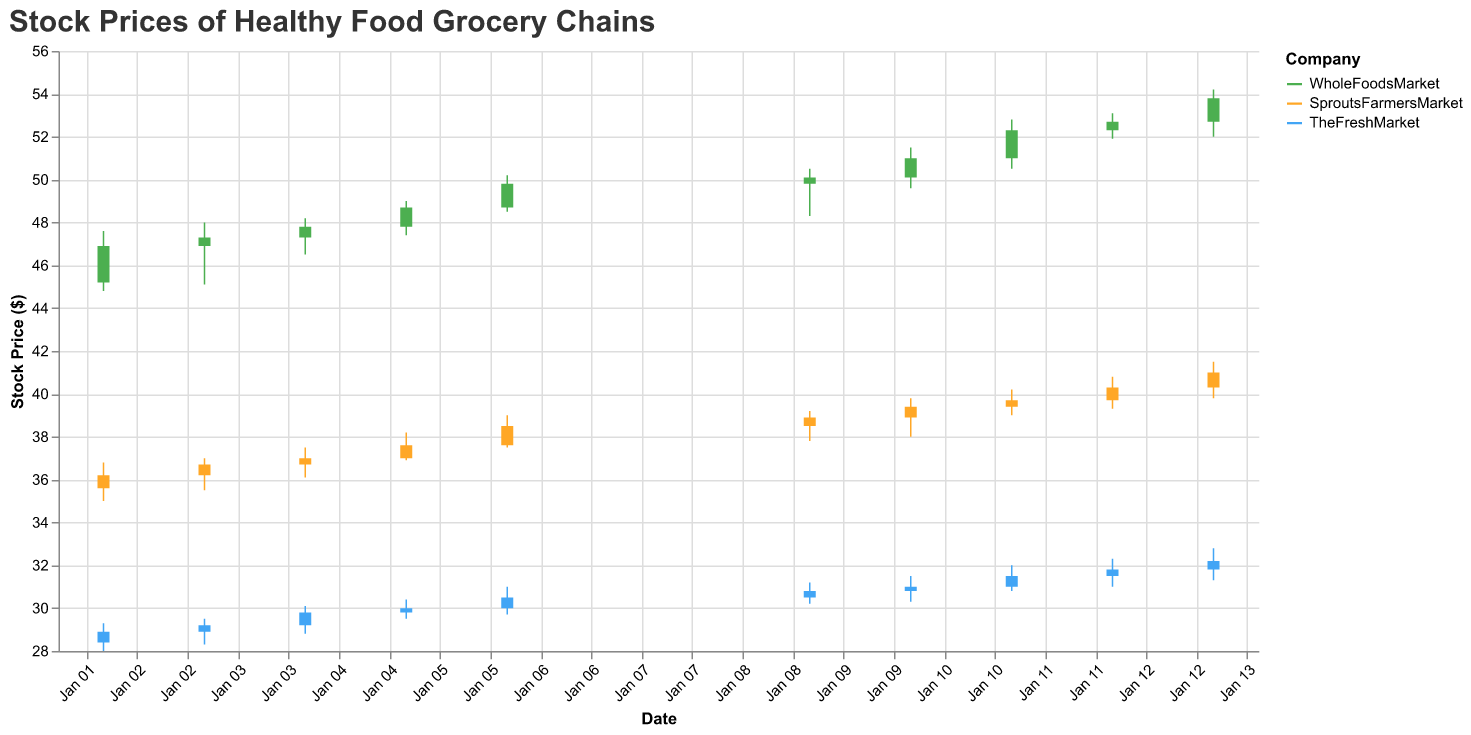What is the overall trend in stock prices for WholeFoodsMarket over the given dates? To determine the overall trend, observe the stock prices from January 2nd to January 13th. The closing prices show an upward trend from $46.9 to $53.8 over this period.
Answer: Upward What was the highest stock price recorded for SproutsFarmersMarket during the period? Look for the highest value in the "High" column for SproutsFarmersMarket. The highest value observed is $41.5 on January 13th.
Answer: $41.5 Compare the stock price of TheFreshMarket on January 2 and January 13. Which day had a higher closing price? Look at the closing prices on January 2nd and January 13th for TheFreshMarket. On January 2nd, it was $28.9, and on January 13th, it was $32.2, indicating the latter had a higher closing price.
Answer: January 13 What is the average closing price of WholeFoodsMarket stocks from January 2 to January 13? Sum the closing prices for WholeFoodsMarket from January 2nd to January 13th and then divide by the number of days. (46.9 + 47.3 + 47.8 + 48.7 + 49.8 + 50.1 + 51.0 + 52.3 + 52.7 + 53.8) / 10 = 50.24
Answer: $50.24 By how much did the closing price of SproutsFarmersMarket increase from January 2 to January 13? Subtract the closing price on January 2nd from the closing price on January 13th for SproutsFarmersMarket. $41.0 (Jan 13) - $36.2 (Jan 2) = $4.8
Answer: $4.8 What was the maximum volume of trades recorded for any company on any given day? Review the "Volume" column and find the highest value across all companies. The maximum trade volume was 240,000 for WholeFoodsMarket on January 13th.
Answer: 240,000 Which company recorded the highest stock price on January 10? Look at the "High" column for January 10 across all three companies. WholeFoodsMarket recorded the highest price at $51.5.
Answer: WholeFoodsMarket On what date did TheFreshMarket's stock price have its lowest value, and what was it? Check the "Low" column for TheFreshMarket to find the minimum value and corresponding date. The lowest value was $28.0 on January 2nd.
Answer: January 2, $28.0 How does the stock price volatility (difference between high and low) on January 6 compare among the three companies? Calculate the difference between "High" and "Low" for each company on January 6. For WholeFoodsMarket: 50.2 - 48.5 = 1.7, SproutsFarmersMarket: 39.0 - 37.5 = 1.5, TheFreshMarket: 31.0 - 29.7 = 1.3. WholeFoodsMarket has the highest volatility.
Answer: WholeFoodsMarket Which company showed consistent growth in closing prices from January 2 to January 13 without any declines? Examine the closing prices for each company to identify any declines. TheFreshMarket consistently grew its closing prices from $28.9 to $32.2 without any declines.
Answer: TheFreshMarket 